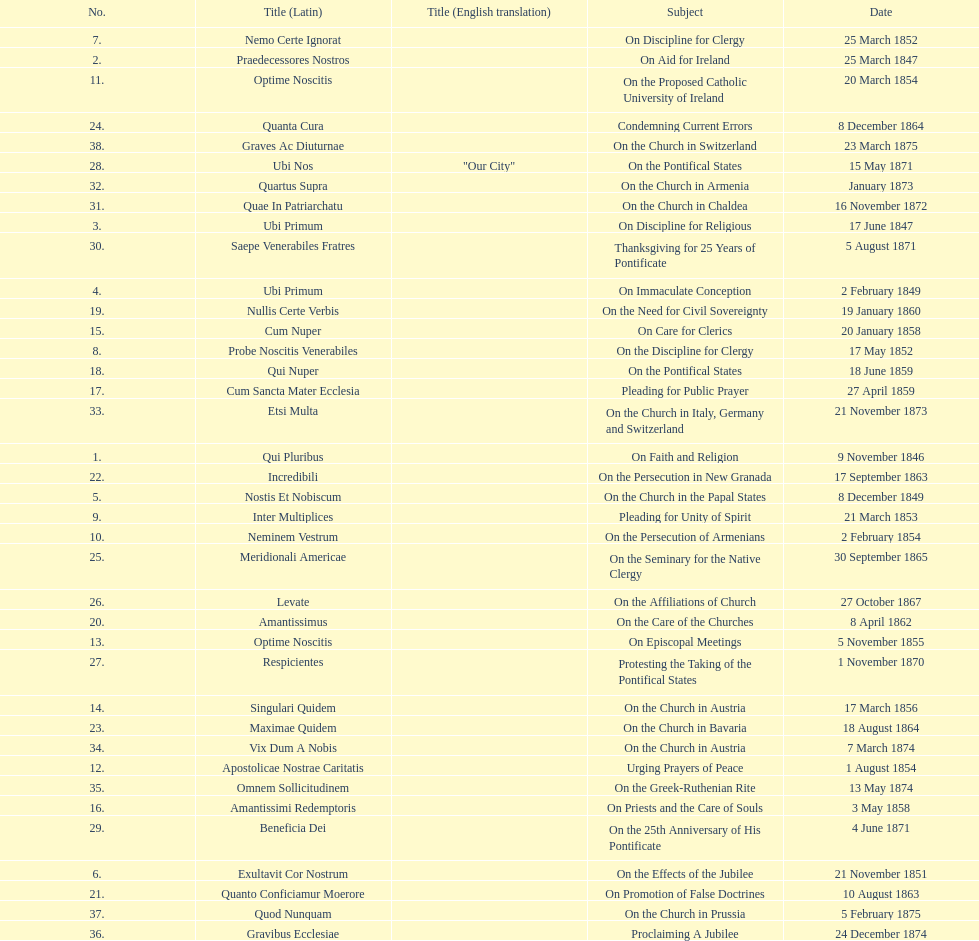What is the last title? Graves Ac Diuturnae. 